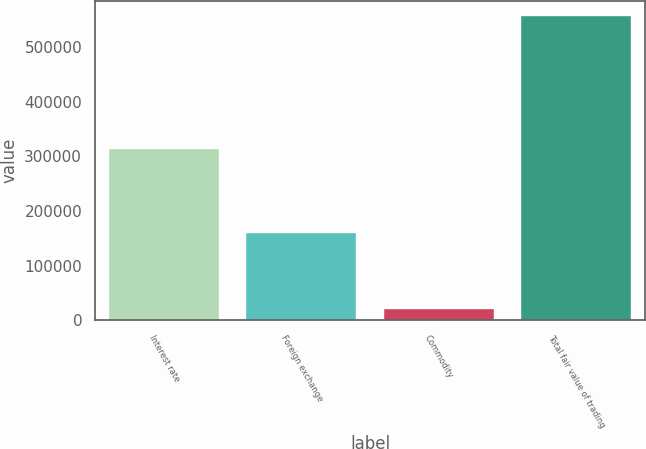Convert chart. <chart><loc_0><loc_0><loc_500><loc_500><bar_chart><fcel>Interest rate<fcel>Foreign exchange<fcel>Commodity<fcel>Total fair value of trading<nl><fcel>313276<fcel>159740<fcel>20066<fcel>556327<nl></chart> 